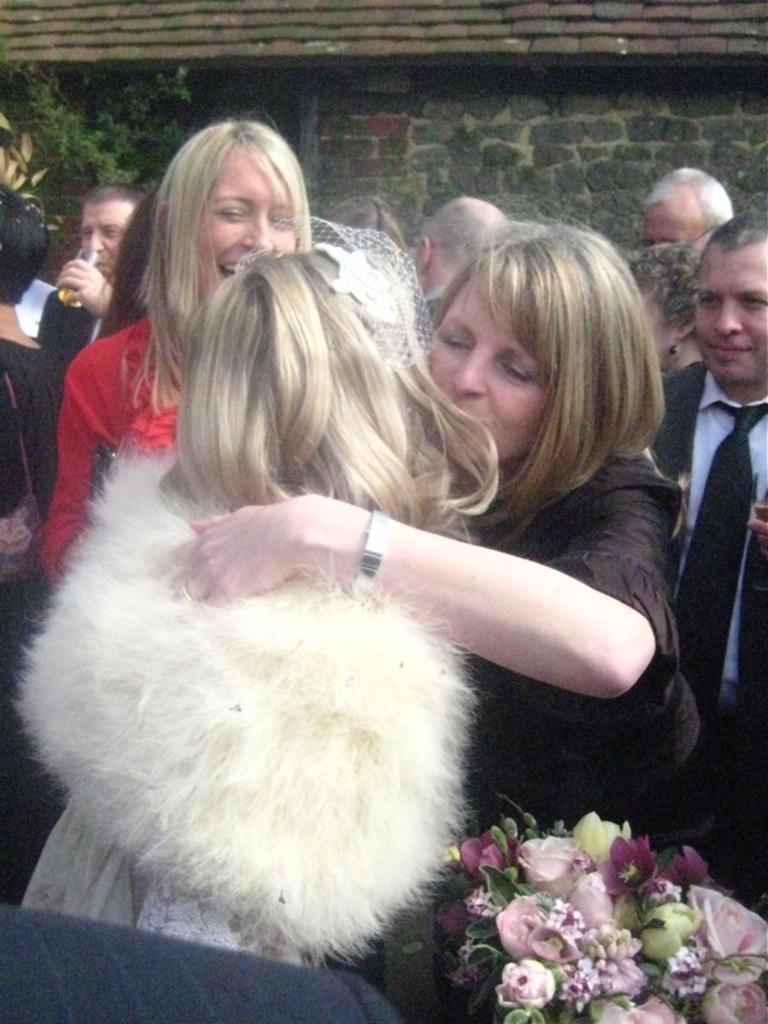Could you give a brief overview of what you see in this image? There are two women hugging and standing, near a woman who is in red color t-shirt, standing and laughing. In the background, there are other persons standing. In front of them, there is a flower bookey. In the background, there is wall of the building near plants. 